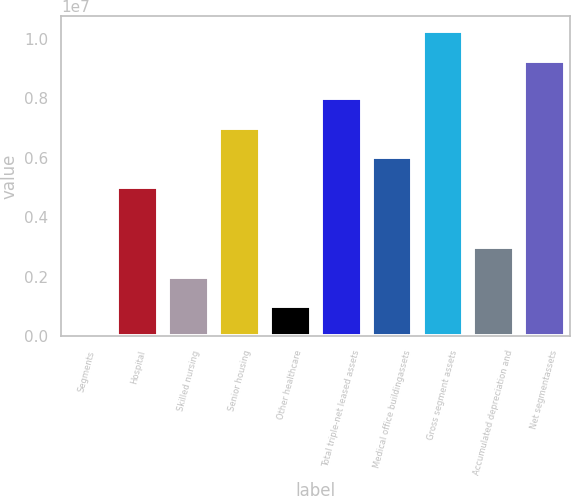Convert chart. <chart><loc_0><loc_0><loc_500><loc_500><bar_chart><fcel>Segments<fcel>Hospital<fcel>Skilled nursing<fcel>Senior housing<fcel>Other healthcare<fcel>Total triple-net leased assets<fcel>Medical office buildingassets<fcel>Gross segment assets<fcel>Accumulated depreciation and<fcel>Net segmentassets<nl><fcel>2006<fcel>5.00738e+06<fcel>2.00415e+06<fcel>7.00953e+06<fcel>1.00308e+06<fcel>8.0106e+06<fcel>6.00845e+06<fcel>1.02509e+07<fcel>3.00523e+06<fcel>9.24979e+06<nl></chart> 